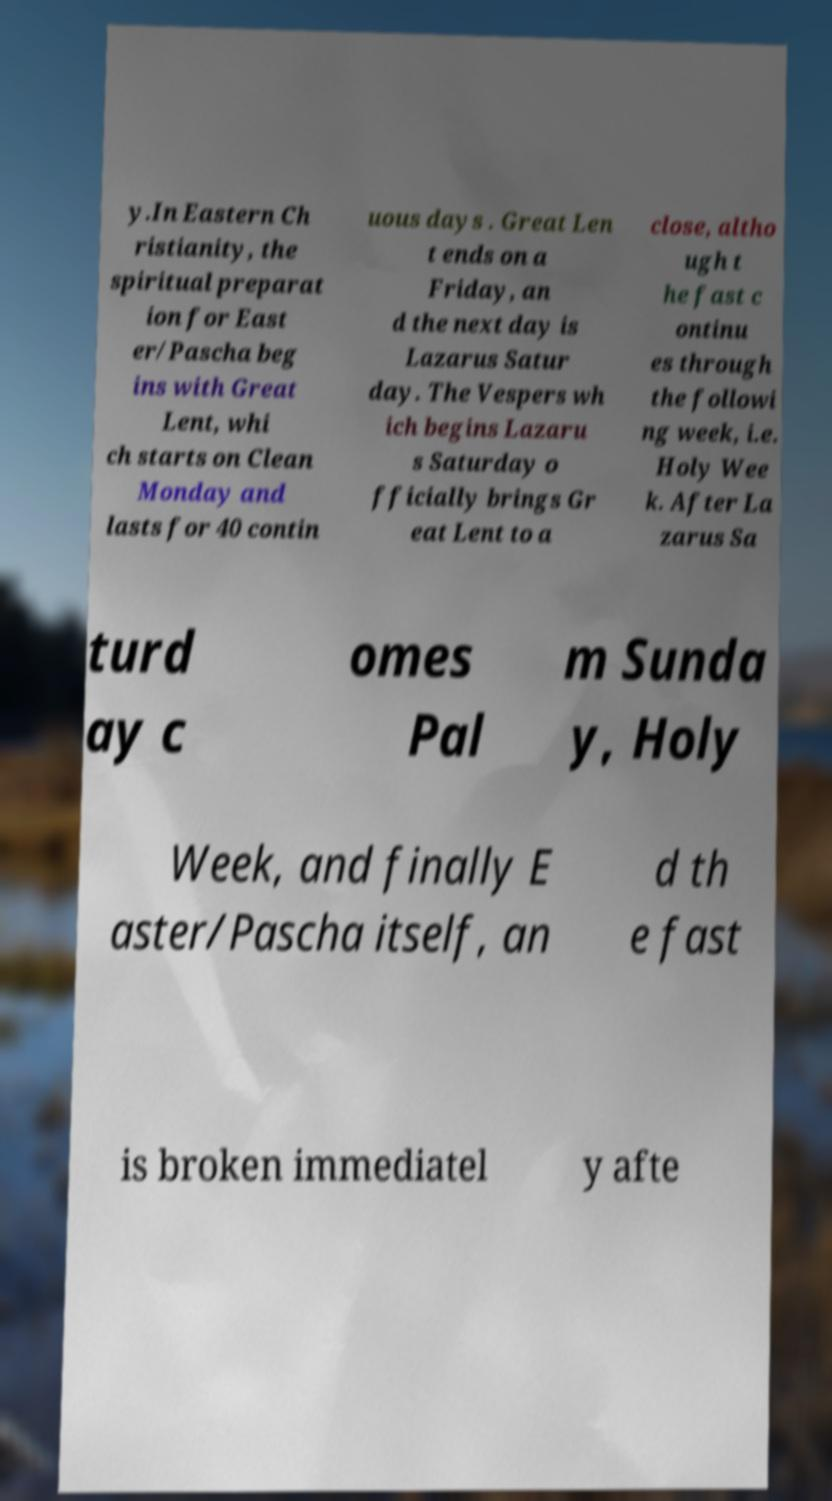There's text embedded in this image that I need extracted. Can you transcribe it verbatim? y.In Eastern Ch ristianity, the spiritual preparat ion for East er/Pascha beg ins with Great Lent, whi ch starts on Clean Monday and lasts for 40 contin uous days . Great Len t ends on a Friday, an d the next day is Lazarus Satur day. The Vespers wh ich begins Lazaru s Saturday o fficially brings Gr eat Lent to a close, altho ugh t he fast c ontinu es through the followi ng week, i.e. Holy Wee k. After La zarus Sa turd ay c omes Pal m Sunda y, Holy Week, and finally E aster/Pascha itself, an d th e fast is broken immediatel y afte 